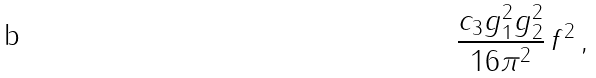<formula> <loc_0><loc_0><loc_500><loc_500>\frac { c _ { 3 } g _ { 1 } ^ { 2 } g _ { 2 } ^ { 2 } } { 1 6 \pi ^ { 2 } } \, f ^ { 2 } \, ,</formula> 